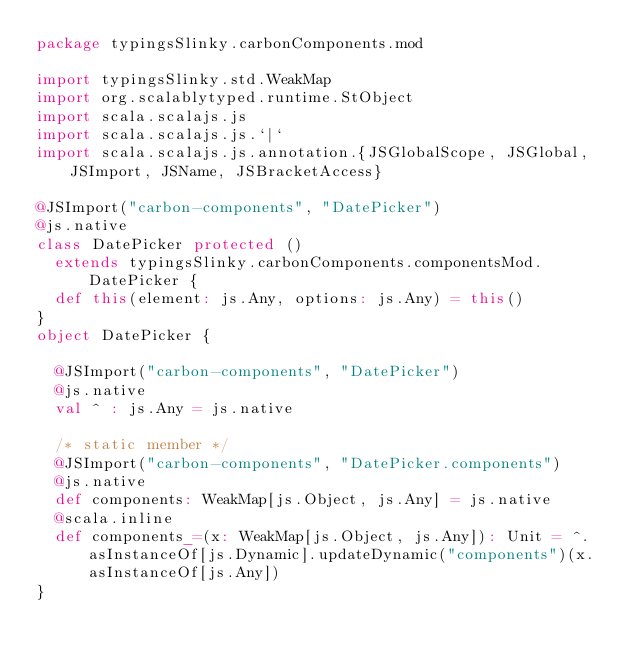Convert code to text. <code><loc_0><loc_0><loc_500><loc_500><_Scala_>package typingsSlinky.carbonComponents.mod

import typingsSlinky.std.WeakMap
import org.scalablytyped.runtime.StObject
import scala.scalajs.js
import scala.scalajs.js.`|`
import scala.scalajs.js.annotation.{JSGlobalScope, JSGlobal, JSImport, JSName, JSBracketAccess}

@JSImport("carbon-components", "DatePicker")
@js.native
class DatePicker protected ()
  extends typingsSlinky.carbonComponents.componentsMod.DatePicker {
  def this(element: js.Any, options: js.Any) = this()
}
object DatePicker {
  
  @JSImport("carbon-components", "DatePicker")
  @js.native
  val ^ : js.Any = js.native
  
  /* static member */
  @JSImport("carbon-components", "DatePicker.components")
  @js.native
  def components: WeakMap[js.Object, js.Any] = js.native
  @scala.inline
  def components_=(x: WeakMap[js.Object, js.Any]): Unit = ^.asInstanceOf[js.Dynamic].updateDynamic("components")(x.asInstanceOf[js.Any])
}
</code> 